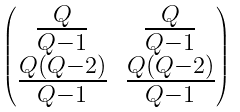Convert formula to latex. <formula><loc_0><loc_0><loc_500><loc_500>\begin{pmatrix} \frac { Q } { Q - 1 } & \frac { Q } { Q - 1 } \\ \frac { Q ( Q - 2 ) } { Q - 1 } & \frac { Q ( Q - 2 ) } { Q - 1 } \end{pmatrix}</formula> 